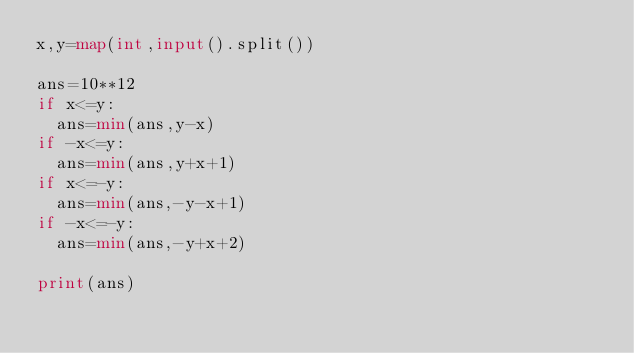Convert code to text. <code><loc_0><loc_0><loc_500><loc_500><_Python_>x,y=map(int,input().split())

ans=10**12
if x<=y:
  ans=min(ans,y-x)
if -x<=y:
  ans=min(ans,y+x+1)
if x<=-y:
  ans=min(ans,-y-x+1)
if -x<=-y:
  ans=min(ans,-y+x+2)

print(ans)
</code> 